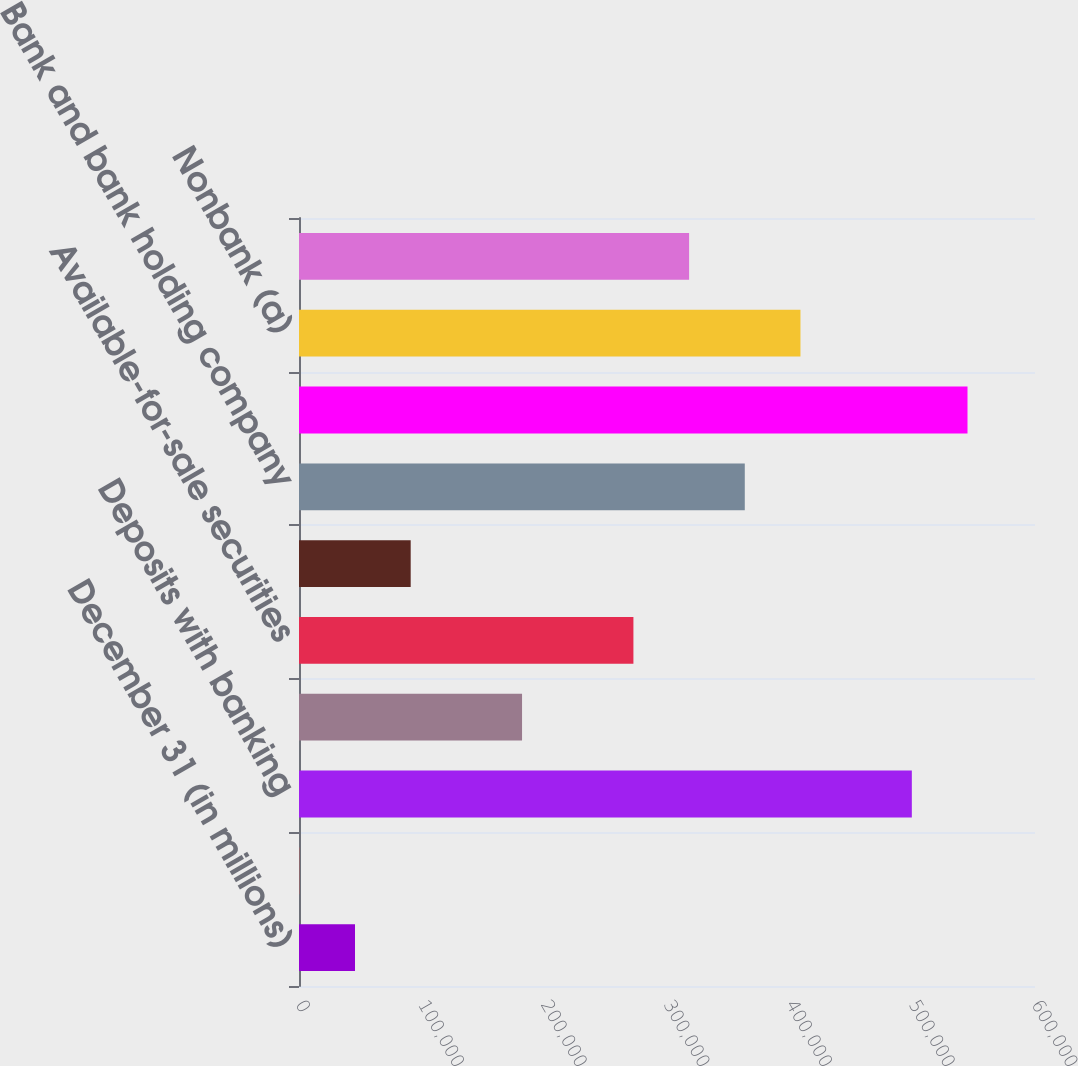<chart> <loc_0><loc_0><loc_500><loc_500><bar_chart><fcel>December 31 (in millions)<fcel>Cash and due from banks<fcel>Deposits with banking<fcel>Trading assets<fcel>Available-for-sale securities<fcel>Loans<fcel>Bank and bank holding company<fcel>Nonbank<fcel>Nonbank (a)<fcel>Other assets<nl><fcel>45657.1<fcel>264<fcel>499588<fcel>181836<fcel>272623<fcel>91050.2<fcel>363409<fcel>544981<fcel>408802<fcel>318016<nl></chart> 